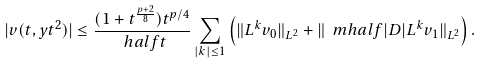<formula> <loc_0><loc_0><loc_500><loc_500>| v ( t , y t ^ { 2 } ) | \leq \frac { ( 1 + t ^ { \frac { p + 2 } { 8 } } ) t ^ { p / 4 } } { \ h a l f { t } } \sum _ { | k | \leq 1 } \left ( \| L ^ { k } v _ { 0 } \| _ { L ^ { 2 } } + \| \ m h a l f { | D | } L ^ { k } v _ { 1 } \| _ { L ^ { 2 } } \right ) .</formula> 